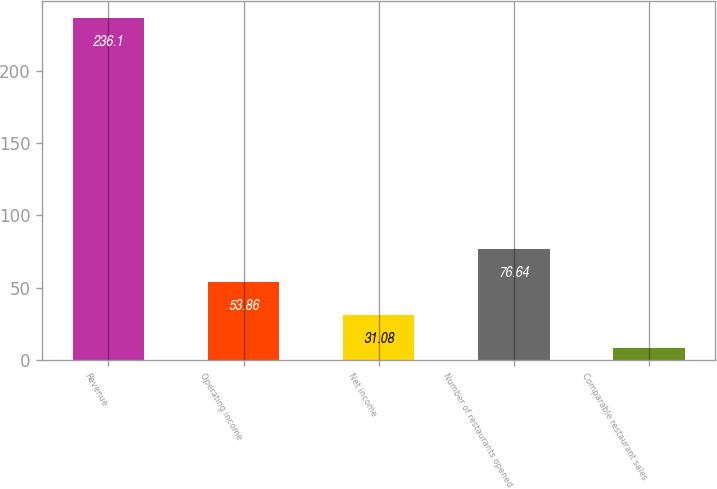Convert chart to OTSL. <chart><loc_0><loc_0><loc_500><loc_500><bar_chart><fcel>Revenue<fcel>Operating income<fcel>Net income<fcel>Number of restaurants opened<fcel>Comparable restaurant sales<nl><fcel>236.1<fcel>53.86<fcel>31.08<fcel>76.64<fcel>8.3<nl></chart> 